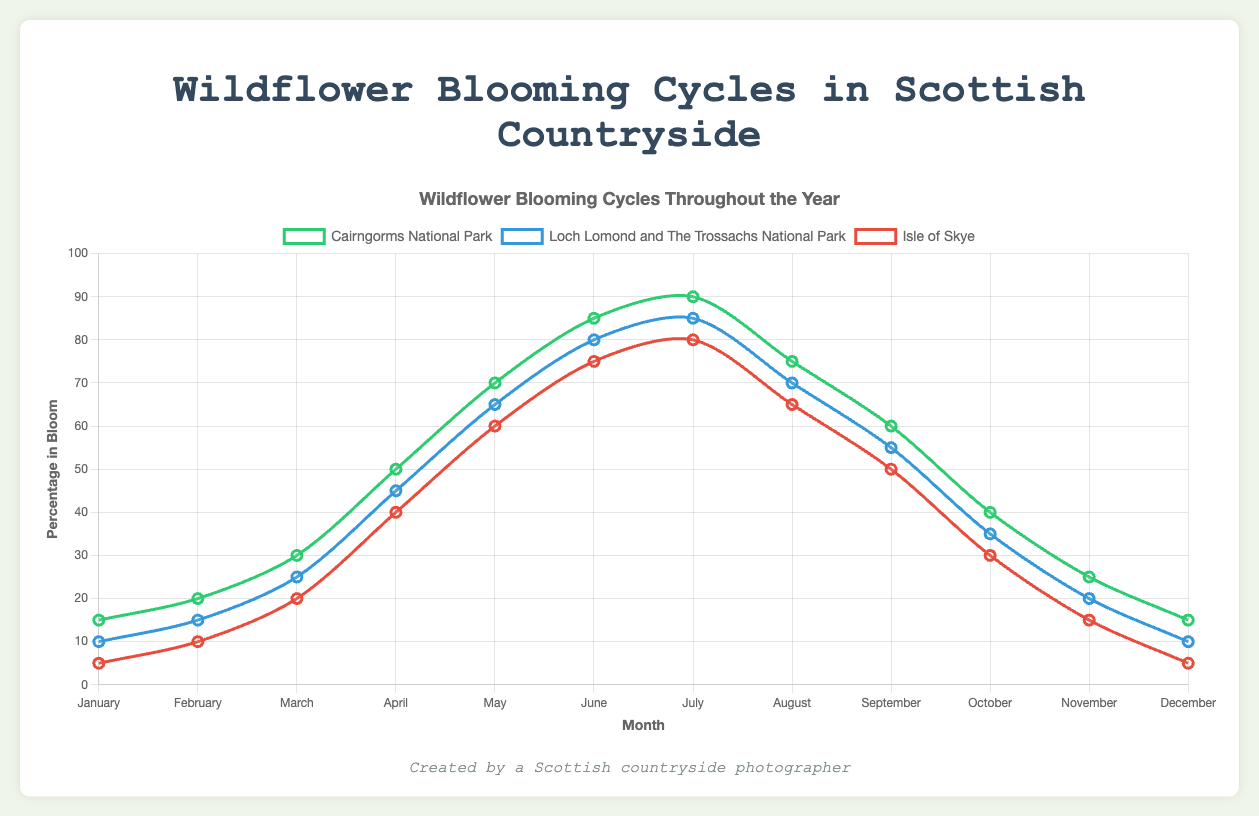What is the highest percentage of wildflowers in bloom in the Cairngorms National Park, and in which month does it occur? Look at the line corresponding to Cairngorms National Park on the chart. Identify the peak point, which is in July, with 90%.
Answer: July, 90% During which month does Loch Lomond and The Trossachs National Park have the same percentage of wildflowers in bloom as Isle of Skye in June? First, identify the percentage of wildflowers in bloom for Isle of Skye in June, which is 75%. Then find the month in Loch Lomond and The Trossachs that corresponds to 75%, which is June.
Answer: June Which location has the lowest percentage of wildflowers in bloom in January? Compare the values for January across all three locations. Isle of Skye has the lowest value at 5%.
Answer: Isle of Skye What is the average percentage of wildflowers in bloom across all three locations in March? Add the percentages for Cairngorms National Park (30%), Loch Lomond and The Trossachs (25%), and Isle of Skye (20%). Then divide by 3. (30 + 25 + 20) / 3 = 25.
Answer: 25% Compare the months of April and October. Which location shows the greatest difference in the percentage of wildflowers in bloom between these two months? Calculate the differences for each location between April and October. Cairngorms (50 - 40 = 10), Loch Lomond and The Trossachs (45 - 35 = 10), Isle of Skye (40 - 30 = 10). All three locations have a difference of 10%. So the answer should consider the explicit comparison, stating they are all equal.
Answer: Equal In which two consecutive months does the Cairngorms National Park experience the largest increase in wildflowers in bloom? Look at the monthly changes in Cairngorms National Park. The largest increase is from April (50%) to May (70%), which is a 20% increase.
Answer: April to May What is the average percentage of wildflowers in bloom in the Isle of Skye during the summer months (June, July, August)? Add the percentages for June (75%), July (80%), and August (65%) for Isle of Skye. Then divide by 3. (75 + 80 + 65) / 3 = 73.33.
Answer: 73.33 Which location shows a consistent increase in the percentage of wildflowers in bloom from January to July? Examine the plots for each location. The Cairngorms National Park shows consistent increase from January (15%) to July (90%).
Answer: Cairngorms National Park What is the difference in the percentage of wildflowers in bloom between the Isle of Skye and Loch Lomond in November? Subtract the percentage for Isle of Skye in November (15%) from Loch Lomond and The Trossachs (20%). 20 - 15 = 5.
Answer: 5 What color is used to represent Loch Lomond and The Trossachs National Park on the chart? Identify the color designated to Loch Lomond and The Trossachs line in the chart. It is blue based on the code provided.
Answer: Blue 